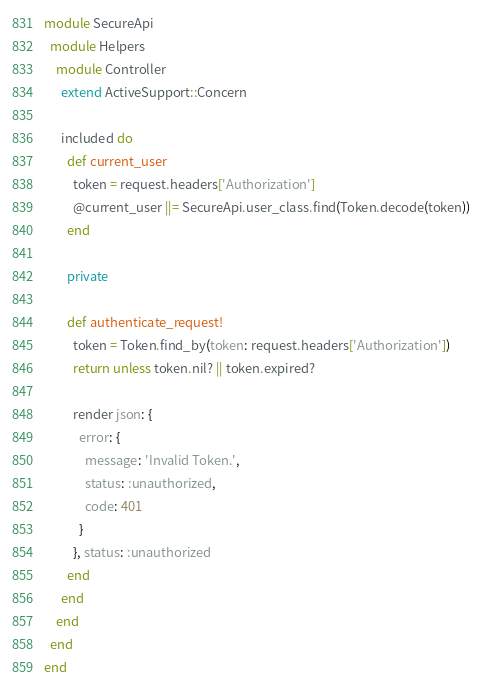<code> <loc_0><loc_0><loc_500><loc_500><_Ruby_>module SecureApi
  module Helpers
    module Controller
      extend ActiveSupport::Concern

      included do
        def current_user
          token = request.headers['Authorization']
          @current_user ||= SecureApi.user_class.find(Token.decode(token))
        end

        private

        def authenticate_request!
          token = Token.find_by(token: request.headers['Authorization'])
          return unless token.nil? || token.expired?

          render json: {
            error: {
              message: 'Invalid Token.',
              status: :unauthorized,
              code: 401
            }
          }, status: :unauthorized
        end
      end
    end
  end
end
</code> 